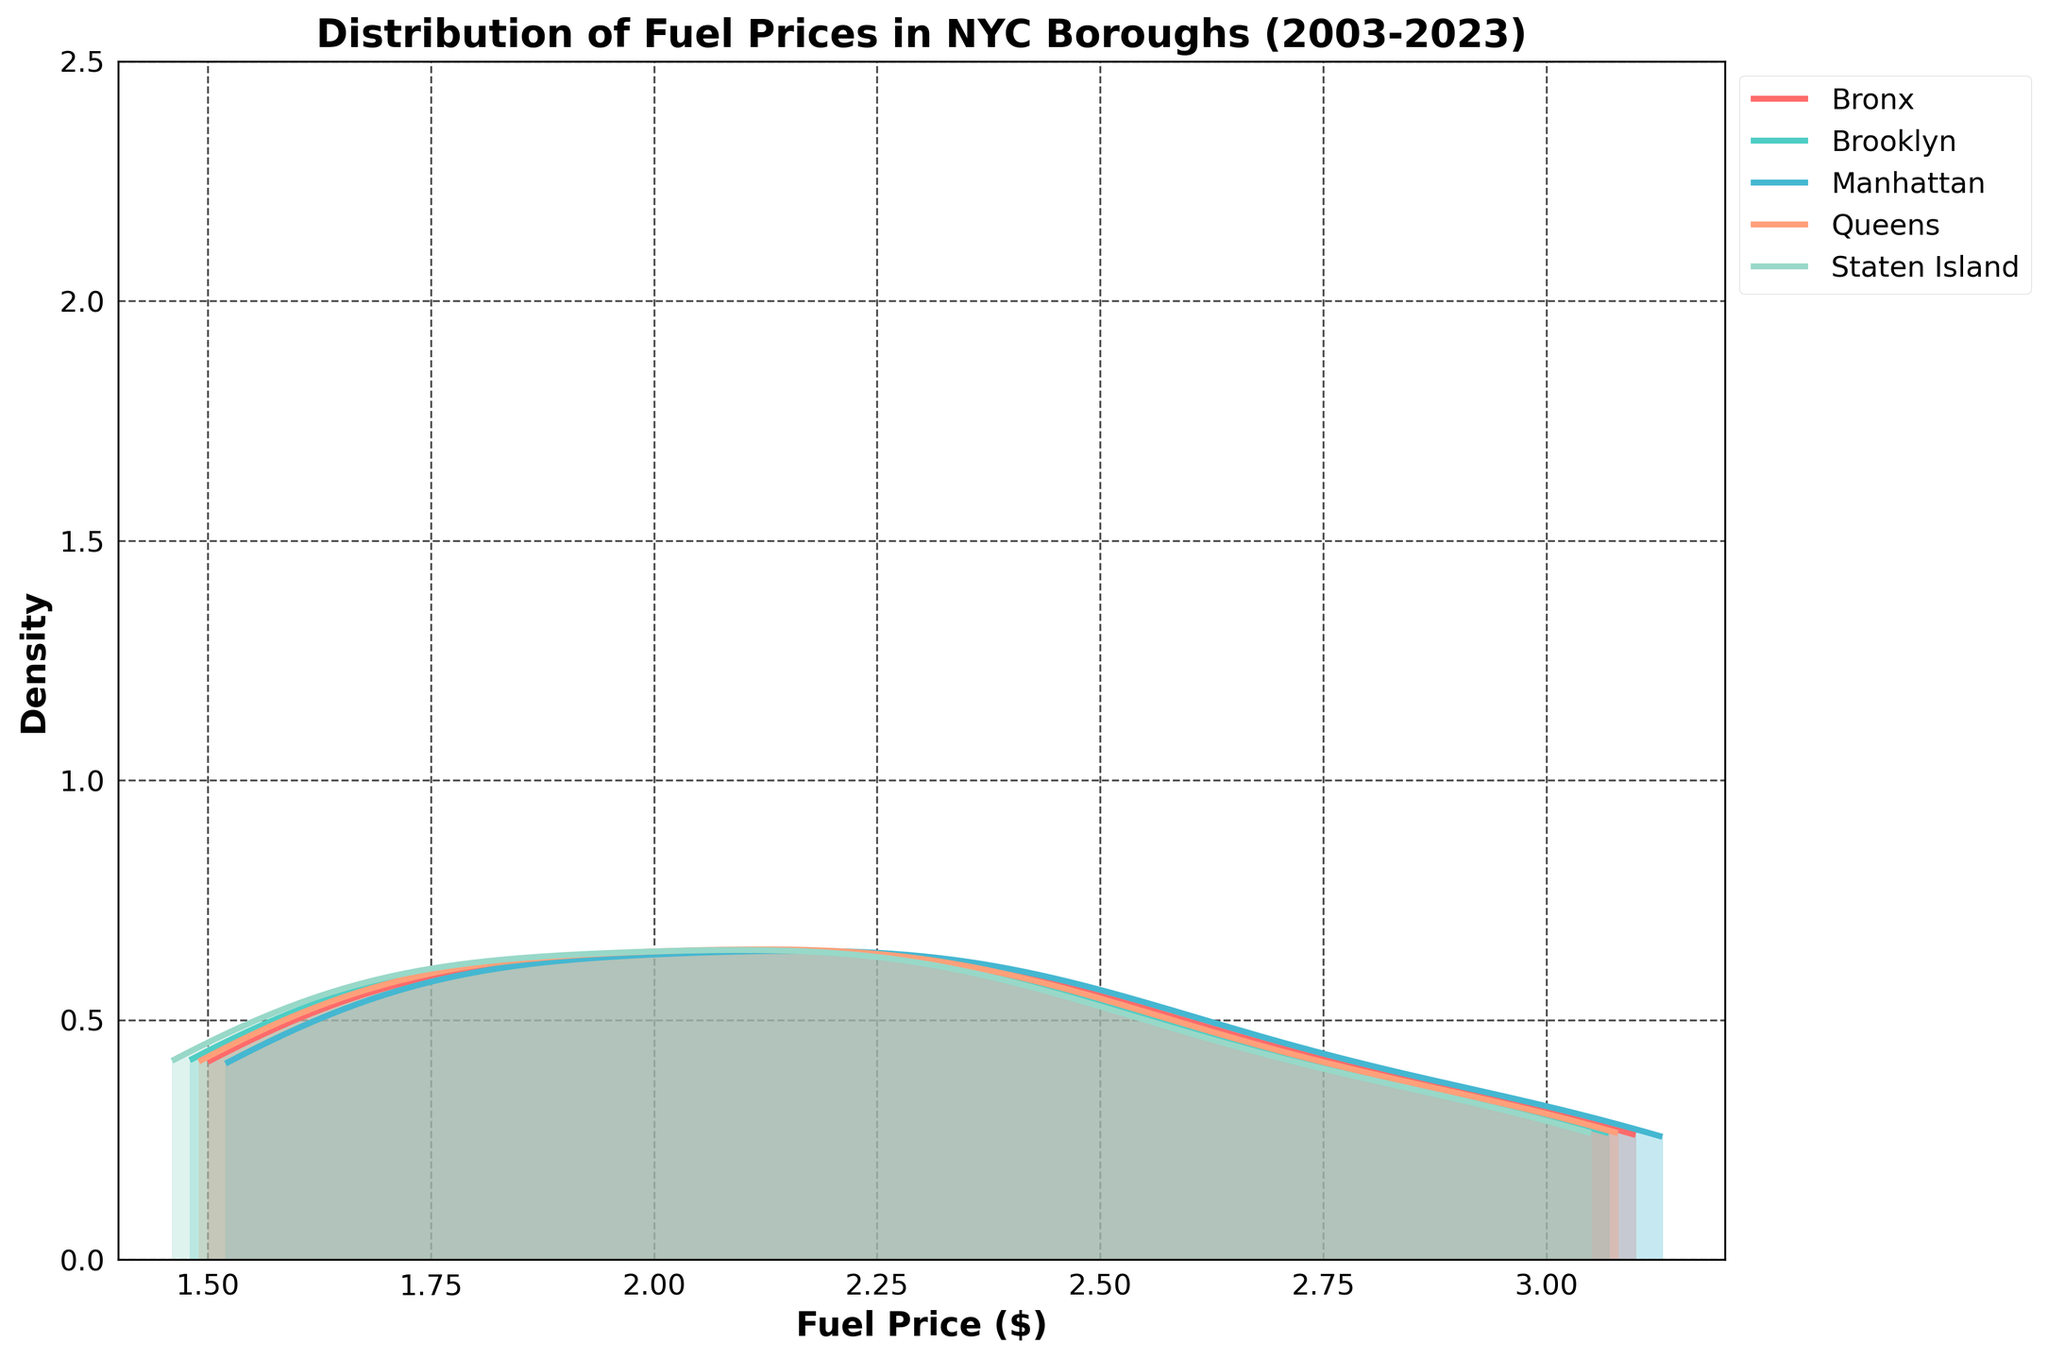What is the title of the plot? The title of the plot is displayed at the top of the figure. It describes the overall topic or the data being visualized.
Answer: Distribution of Fuel Prices in NYC Boroughs (2003-2023) What does the x-axis represent? The x-axis represents the variable being measured in the data set. It is labeled to indicate what is plotted along this axis.
Answer: Fuel Price ($) Which borough has the highest peak density in fuel prices? By observing the height of the peak density curves, we can determine the maximum density for each borough. The peak that reaches the highest point indicates the borough with the highest density.
Answer: Manhattan Which color represents Staten Island? The colors for different boroughs are indicated by the legend on the right-hand side of the plot. You can match the color to the corresponding borough.
Answer: Light green What is the range of fuel prices shown on the x-axis? To find the range, observe the minimum and maximum values indicated on the x-axis.
Answer: $1.4 to $3.2 Which borough has the lowest minimum fuel price? By examining the leftmost points of each line drawn in the plot, you can determine which borough's density plot starts at the lowest fuel price value.
Answer: Staten Island How does the density pattern for Brooklyn compare to Queens? To compare the density patterns, look at the shapes, peaks, and spreads of the density curves for Brooklyn and Queens. Notice any similarities or differences in their distributions.
Answer: Brooklyn generally has a higher density around the middle range than Queens What is the fuel price where the Bronx and Manhattan density lines cross? To find the crossing point, look for the intersection of the density curves for Bronx and Manhattan on the plot. The x-coordinate of this intersection gives the fuel price.
Answer: Around $2.1 Which borough has the narrowest spread in fuel prices? The spread can be assessed by looking at how widespread or narrow the density curve is for each borough along the x-axis. The narrowest curve corresponds to the borough with the narrowest spread in fuel prices.
Answer: Bronx Are there any boroughs with bimodal distributions? A bimodal distribution has two distinct peaks in the density plot. Examine each borough's density curve to see if any of them have two separate peaks or modes.
Answer: No 